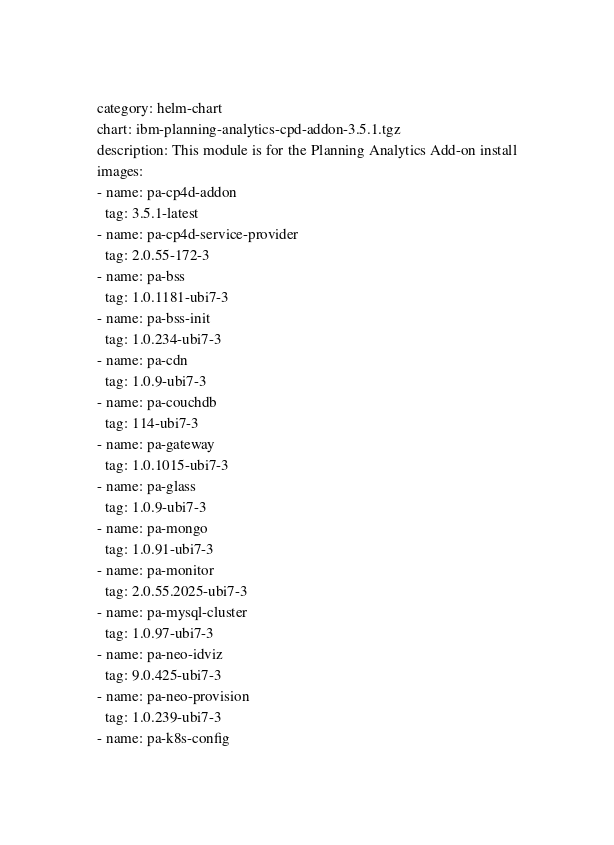Convert code to text. <code><loc_0><loc_0><loc_500><loc_500><_YAML_>category: helm-chart
chart: ibm-planning-analytics-cpd-addon-3.5.1.tgz
description: This module is for the Planning Analytics Add-on install
images:
- name: pa-cp4d-addon
  tag: 3.5.1-latest
- name: pa-cp4d-service-provider
  tag: 2.0.55-172-3
- name: pa-bss
  tag: 1.0.1181-ubi7-3
- name: pa-bss-init
  tag: 1.0.234-ubi7-3
- name: pa-cdn
  tag: 1.0.9-ubi7-3
- name: pa-couchdb
  tag: 114-ubi7-3
- name: pa-gateway
  tag: 1.0.1015-ubi7-3
- name: pa-glass
  tag: 1.0.9-ubi7-3
- name: pa-mongo
  tag: 1.0.91-ubi7-3
- name: pa-monitor
  tag: 2.0.55.2025-ubi7-3
- name: pa-mysql-cluster
  tag: 1.0.97-ubi7-3
- name: pa-neo-idviz
  tag: 9.0.425-ubi7-3
- name: pa-neo-provision
  tag: 1.0.239-ubi7-3
- name: pa-k8s-config</code> 